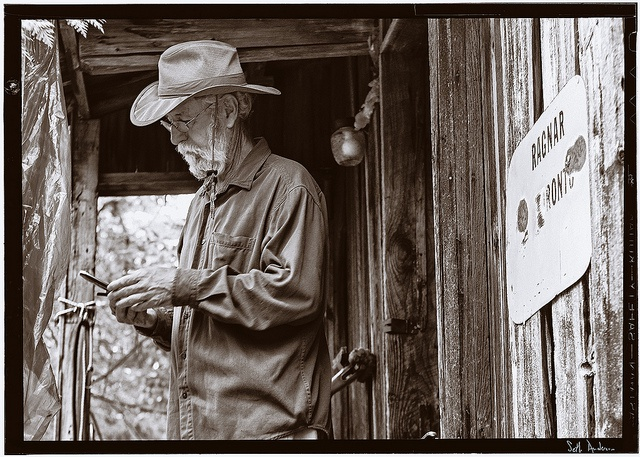Describe the objects in this image and their specific colors. I can see people in white, gray, black, and darkgray tones and cell phone in white, black, and gray tones in this image. 